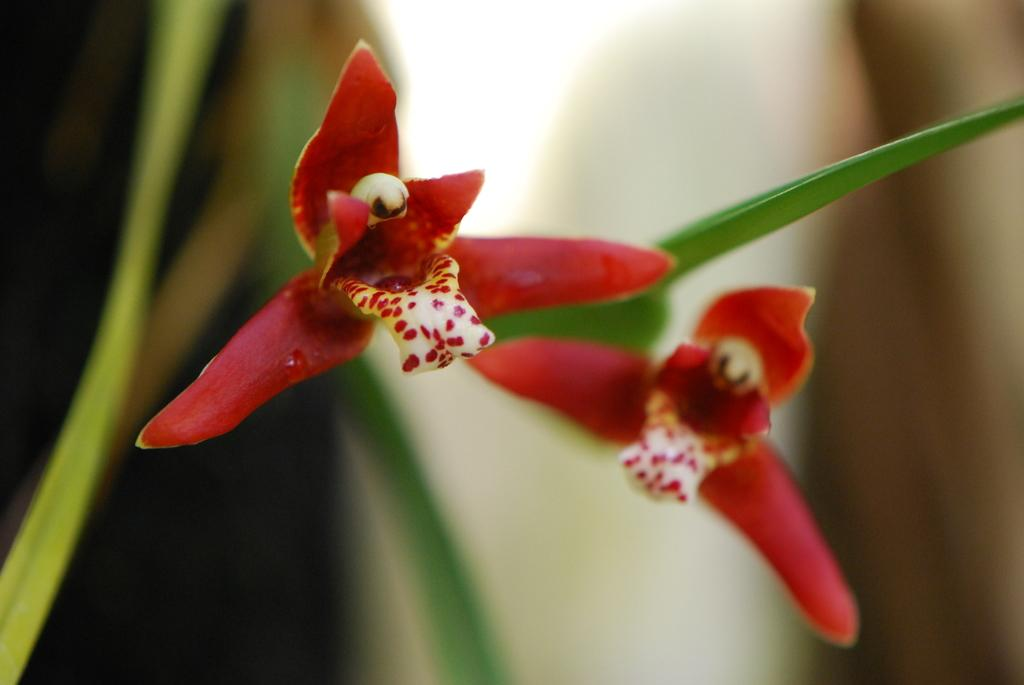What type of plants can be seen in the image? There are flowers and leaves in the image. Can you describe the background of the image? The background of the image is blurred. How many cents are visible on the plate in the image? There is no plate or cent present in the image. What word is written on the leaves in the image? There are no words written on the leaves in the image. 